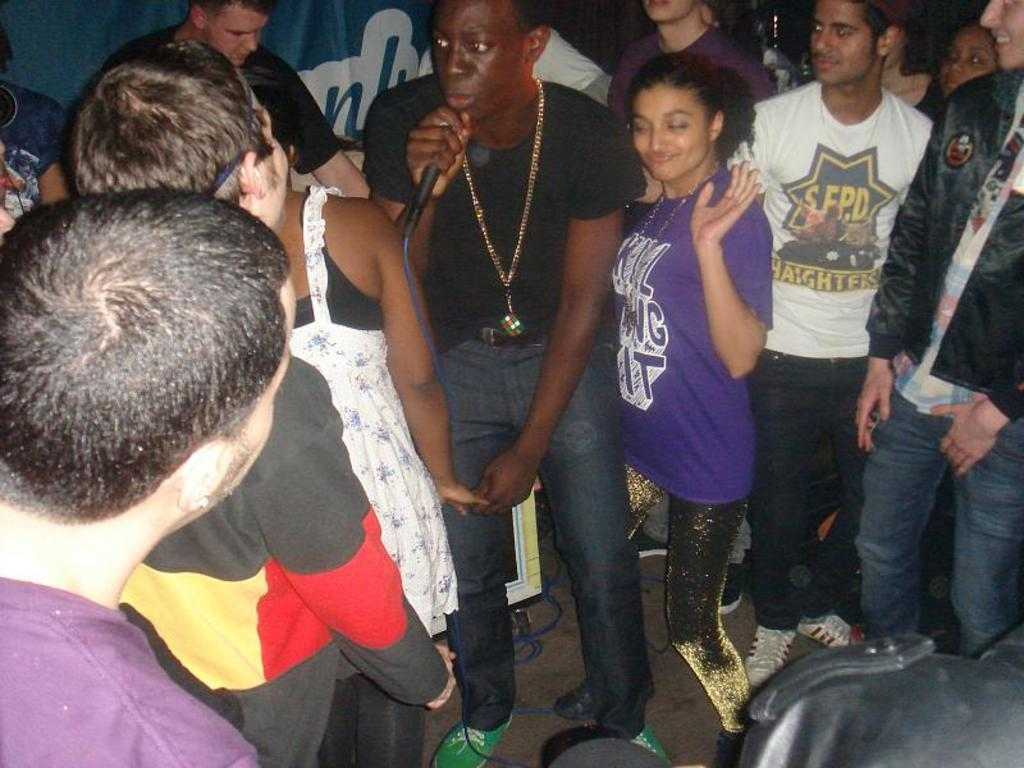How many people are in the image? There are persons standing in the image. What is the man holding in his hand? A man is holding a microphone in his hand. What can be seen in the background of the image? There is a banner in the background of the image. How many times has the man folded his vest in the image? There is no mention of a vest in the image, so it cannot be determined if it has been folded or how many times. 